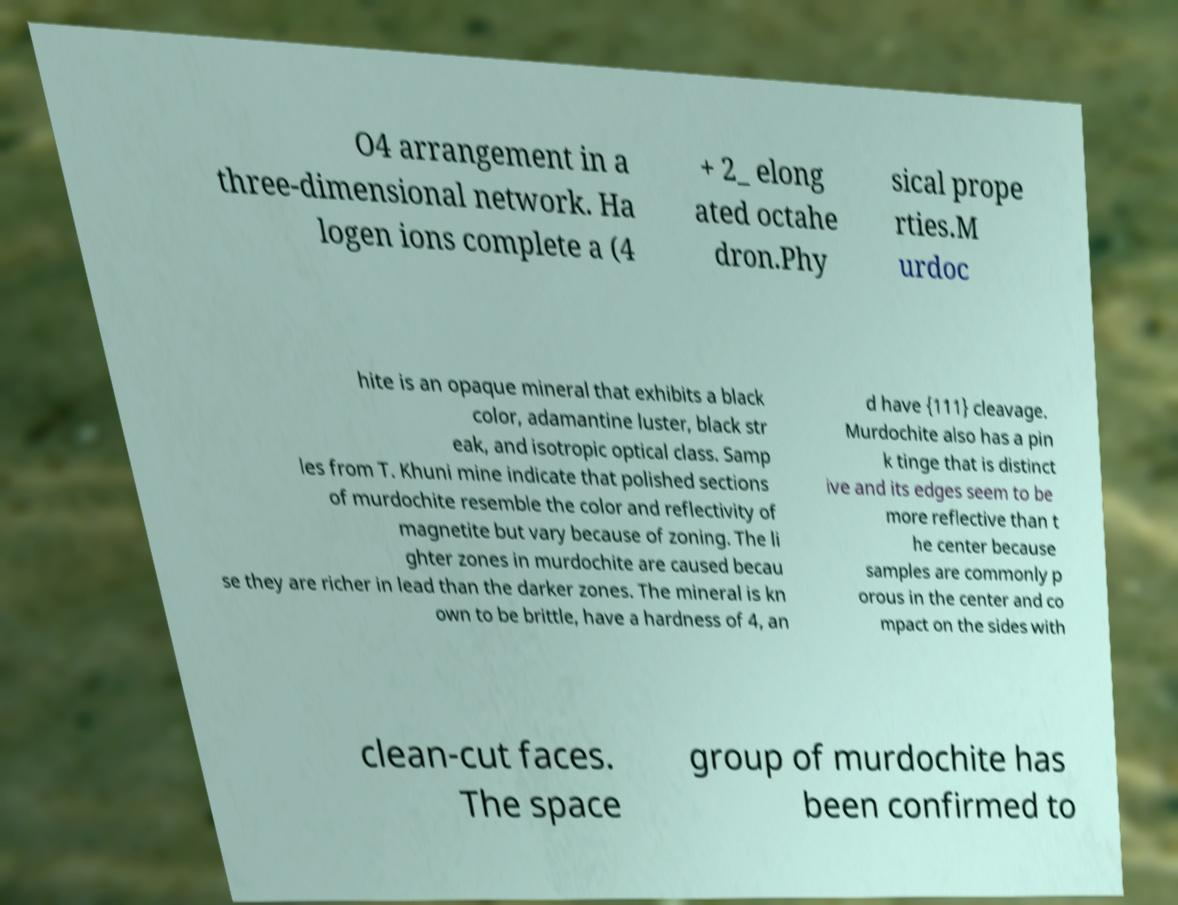For documentation purposes, I need the text within this image transcribed. Could you provide that? O4 arrangement in a three-dimensional network. Ha logen ions complete a (4 + 2_ elong ated octahe dron.Phy sical prope rties.M urdoc hite is an opaque mineral that exhibits a black color, adamantine luster, black str eak, and isotropic optical class. Samp les from T. Khuni mine indicate that polished sections of murdochite resemble the color and reflectivity of magnetite but vary because of zoning. The li ghter zones in murdochite are caused becau se they are richer in lead than the darker zones. The mineral is kn own to be brittle, have a hardness of 4, an d have {111} cleavage. Murdochite also has a pin k tinge that is distinct ive and its edges seem to be more reflective than t he center because samples are commonly p orous in the center and co mpact on the sides with clean-cut faces. The space group of murdochite has been confirmed to 